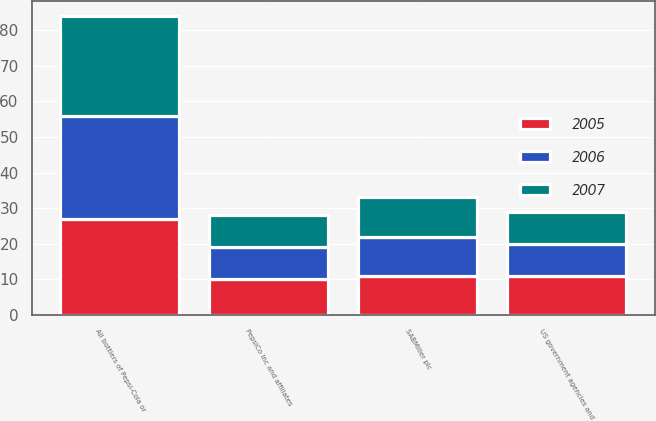Convert chart. <chart><loc_0><loc_0><loc_500><loc_500><stacked_bar_chart><ecel><fcel>SABMiller plc<fcel>PepsiCo Inc and affiliates<fcel>All bottlers of Pepsi-Cola or<fcel>US government agencies and<nl><fcel>2007<fcel>11<fcel>9<fcel>28<fcel>9<nl><fcel>2006<fcel>11<fcel>9<fcel>29<fcel>9<nl><fcel>2005<fcel>11<fcel>10<fcel>27<fcel>11<nl></chart> 